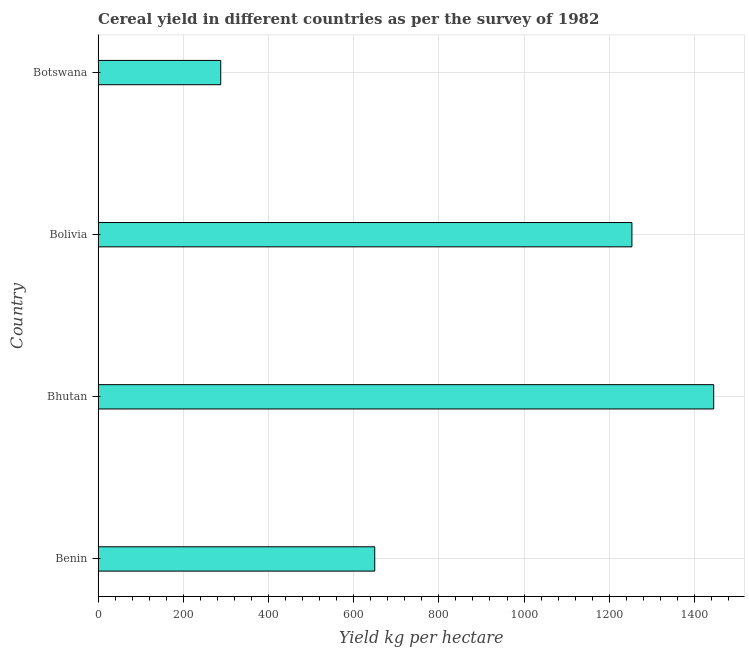Does the graph contain any zero values?
Make the answer very short. No. What is the title of the graph?
Provide a short and direct response. Cereal yield in different countries as per the survey of 1982. What is the label or title of the X-axis?
Make the answer very short. Yield kg per hectare. What is the label or title of the Y-axis?
Your answer should be compact. Country. What is the cereal yield in Bhutan?
Offer a terse response. 1445.27. Across all countries, what is the maximum cereal yield?
Give a very brief answer. 1445.27. Across all countries, what is the minimum cereal yield?
Your answer should be compact. 287.93. In which country was the cereal yield maximum?
Provide a succinct answer. Bhutan. In which country was the cereal yield minimum?
Provide a short and direct response. Botswana. What is the sum of the cereal yield?
Provide a short and direct response. 3635.95. What is the difference between the cereal yield in Bolivia and Botswana?
Ensure brevity in your answer.  965.34. What is the average cereal yield per country?
Your response must be concise. 908.99. What is the median cereal yield?
Give a very brief answer. 951.38. What is the ratio of the cereal yield in Benin to that in Bolivia?
Ensure brevity in your answer.  0.52. What is the difference between the highest and the second highest cereal yield?
Provide a short and direct response. 192. What is the difference between the highest and the lowest cereal yield?
Give a very brief answer. 1157.34. In how many countries, is the cereal yield greater than the average cereal yield taken over all countries?
Your answer should be compact. 2. How many bars are there?
Offer a terse response. 4. Are all the bars in the graph horizontal?
Give a very brief answer. Yes. What is the difference between two consecutive major ticks on the X-axis?
Offer a very short reply. 200. What is the Yield kg per hectare of Benin?
Your answer should be compact. 649.49. What is the Yield kg per hectare of Bhutan?
Give a very brief answer. 1445.27. What is the Yield kg per hectare in Bolivia?
Keep it short and to the point. 1253.26. What is the Yield kg per hectare of Botswana?
Keep it short and to the point. 287.93. What is the difference between the Yield kg per hectare in Benin and Bhutan?
Provide a short and direct response. -795.77. What is the difference between the Yield kg per hectare in Benin and Bolivia?
Provide a short and direct response. -603.77. What is the difference between the Yield kg per hectare in Benin and Botswana?
Your answer should be very brief. 361.56. What is the difference between the Yield kg per hectare in Bhutan and Bolivia?
Make the answer very short. 192. What is the difference between the Yield kg per hectare in Bhutan and Botswana?
Provide a short and direct response. 1157.34. What is the difference between the Yield kg per hectare in Bolivia and Botswana?
Make the answer very short. 965.34. What is the ratio of the Yield kg per hectare in Benin to that in Bhutan?
Make the answer very short. 0.45. What is the ratio of the Yield kg per hectare in Benin to that in Bolivia?
Your answer should be very brief. 0.52. What is the ratio of the Yield kg per hectare in Benin to that in Botswana?
Your response must be concise. 2.26. What is the ratio of the Yield kg per hectare in Bhutan to that in Bolivia?
Give a very brief answer. 1.15. What is the ratio of the Yield kg per hectare in Bhutan to that in Botswana?
Give a very brief answer. 5.02. What is the ratio of the Yield kg per hectare in Bolivia to that in Botswana?
Make the answer very short. 4.35. 